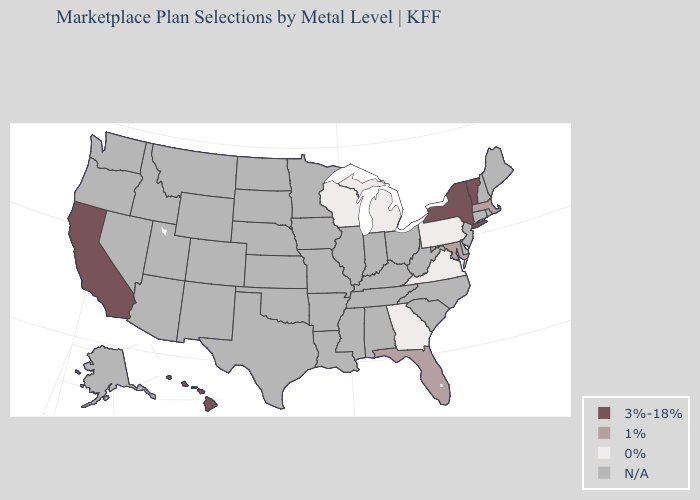What is the value of West Virginia?
Give a very brief answer. N/A. What is the highest value in the USA?
Concise answer only. 3%-18%. What is the value of Oregon?
Concise answer only. N/A. What is the value of Virginia?
Short answer required. 0%. Name the states that have a value in the range N/A?
Keep it brief. Alabama, Alaska, Arizona, Arkansas, Colorado, Connecticut, Delaware, Idaho, Illinois, Indiana, Iowa, Kansas, Kentucky, Louisiana, Maine, Minnesota, Mississippi, Missouri, Montana, Nebraska, Nevada, New Hampshire, New Jersey, New Mexico, North Carolina, North Dakota, Ohio, Oklahoma, Oregon, Rhode Island, South Carolina, South Dakota, Tennessee, Texas, Utah, Washington, West Virginia, Wyoming. What is the highest value in the MidWest ?
Answer briefly. 0%. Is the legend a continuous bar?
Give a very brief answer. No. What is the lowest value in states that border Minnesota?
Write a very short answer. 0%. Name the states that have a value in the range 0%?
Keep it brief. Georgia, Michigan, Pennsylvania, Virginia, Wisconsin. What is the value of Mississippi?
Write a very short answer. N/A. What is the value of Missouri?
Quick response, please. N/A. 